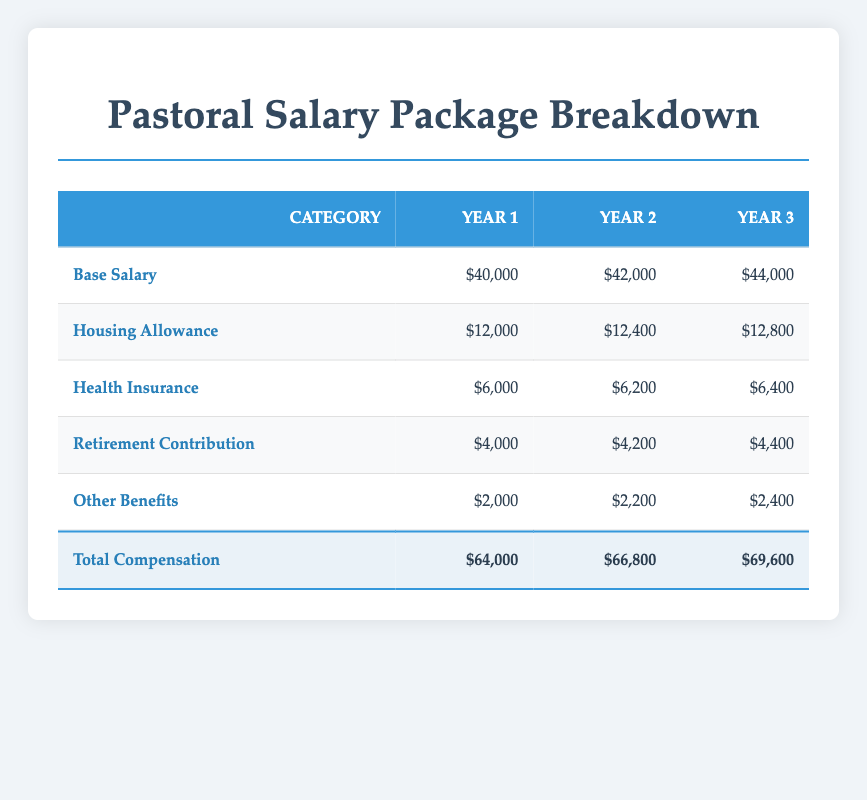What is the total compensation for Year 2? In the table, under Year 2 in the Total Compensation row, it shows the amount $66,800.
Answer: 66,800 How much does the housing allowance increase from Year 1 to Year 3? The housing allowance for Year 1 is $12,000 and for Year 3 is $12,800. The difference is $12,800 - $12,000 = $800.
Answer: 800 Is the total compensation for Year 1 greater than that of Year 3? The total compensation for Year 1 is $64,000 and for Year 3 it is $69,600. Since $64,000 is not greater than $69,600, the statement is false.
Answer: No What is the average base salary over the three years? The base salaries are $40,000, $42,000, and $44,000. The sum is $40,000 + $42,000 + $44,000 = $126,000. The average is $126,000 divided by 3, which equals $42,000.
Answer: 42,000 What is the total amount for health insurance over the three years? The health insurance amounts are $6,000 (Year 1), $6,200 (Year 2), and $6,400 (Year 3). Adding them gives $6,000 + $6,200 + $6,400 = $18,600.
Answer: 18,600 In which year does the total compensation first exceed $67,000? Looking at the Total Compensation row, Year 1 is $64,000, Year 2 is $66,800, and Year 3 is $69,600. The first instance exceeding $67,000 is in Year 3.
Answer: Year 3 What is the difference in retirement contributions between Year 2 and Year 1? The retirement contribution for Year 1 is $4,000 and for Year 2 is $4,200. The difference is $4,200 - $4,000 = $200.
Answer: 200 Which category has the highest total compensation over the three years? To find the highest category, we sum each category across the three years: Base Salary $126,000, Housing Allowance $39,200, Health Insurance $18,600, Retirement $12,600, Other Benefits $6,600. The highest is Base Salary at $126,000.
Answer: Base Salary 